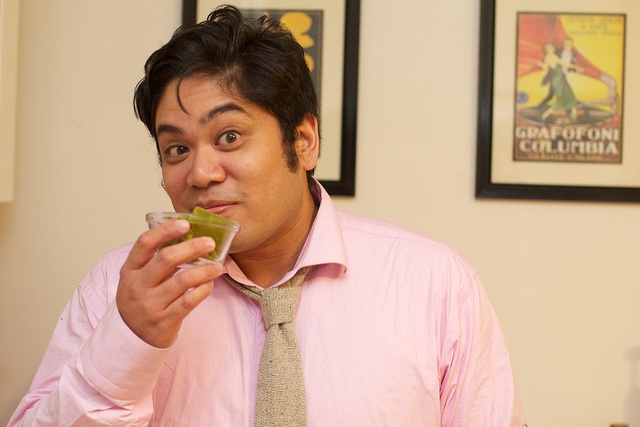Describe the objects in this image and their specific colors. I can see people in tan, pink, lightpink, black, and salmon tones, tie in tan tones, and cup in tan and olive tones in this image. 